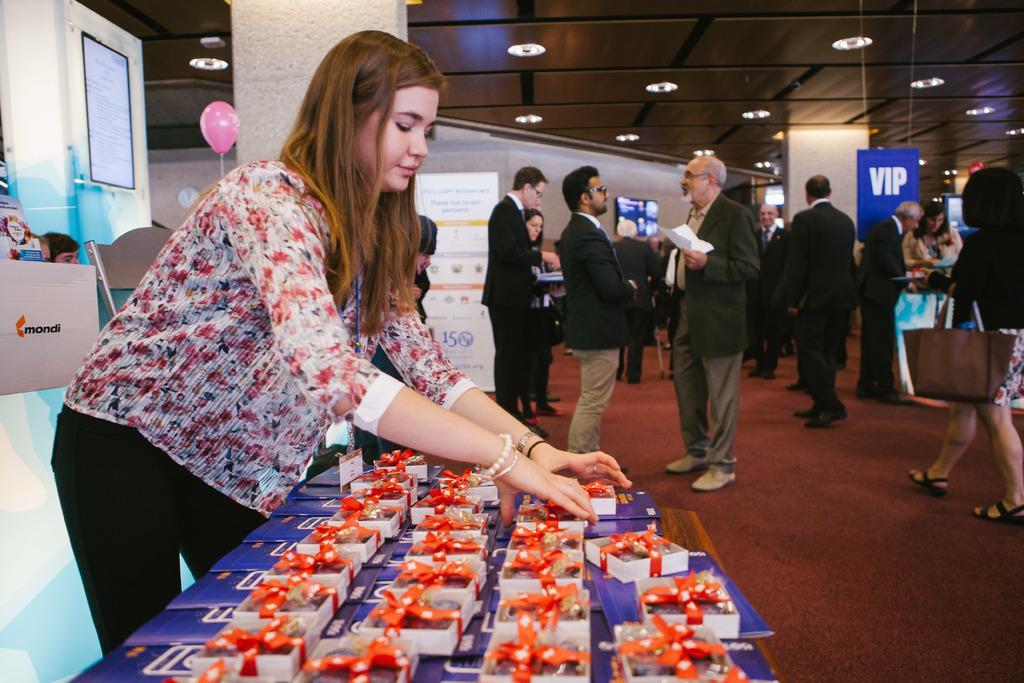Can you describe this image briefly? The woman in front of the picture is standing. In front of her, we see a table on which book color books and gift boxes are placed. Behind her, we see a board in white and blue color. Beside that, we see boards and a man is sitting. Beside her, we see a pillar and a pink color balloon. Behind that, we see a board in white color with some text written on it. In the middle of the picture, we see the people are standing. On the right side, we see a woman who is wearing the handbag is walking. At the bottom, we see the brown carpet. Beside them, we see a pillar and the boards in blue color with some text written on it. In the background, we see a wall. At the top, we see the ceiling of the room. 